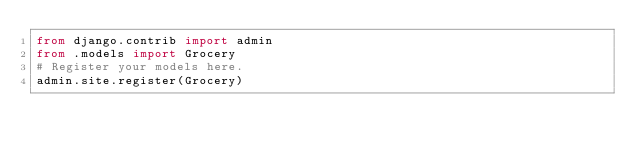Convert code to text. <code><loc_0><loc_0><loc_500><loc_500><_Python_>from django.contrib import admin
from .models import Grocery
# Register your models here.
admin.site.register(Grocery)</code> 